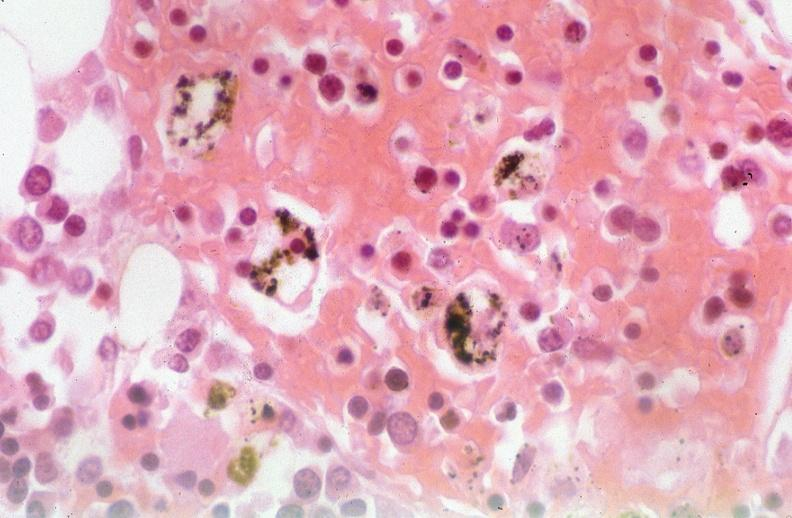how many antitrypsin was talc used to sclerose emphysematous lung, alpha-deficiency?
Answer the question using a single word or phrase. 1 